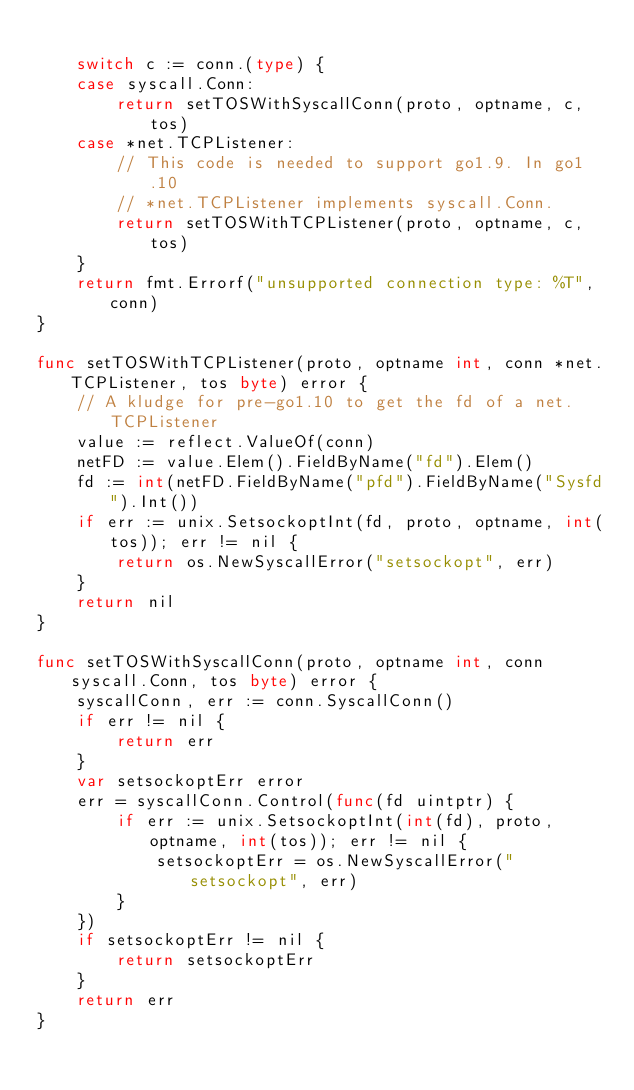<code> <loc_0><loc_0><loc_500><loc_500><_Go_>
	switch c := conn.(type) {
	case syscall.Conn:
		return setTOSWithSyscallConn(proto, optname, c, tos)
	case *net.TCPListener:
		// This code is needed to support go1.9. In go1.10
		// *net.TCPListener implements syscall.Conn.
		return setTOSWithTCPListener(proto, optname, c, tos)
	}
	return fmt.Errorf("unsupported connection type: %T", conn)
}

func setTOSWithTCPListener(proto, optname int, conn *net.TCPListener, tos byte) error {
	// A kludge for pre-go1.10 to get the fd of a net.TCPListener
	value := reflect.ValueOf(conn)
	netFD := value.Elem().FieldByName("fd").Elem()
	fd := int(netFD.FieldByName("pfd").FieldByName("Sysfd").Int())
	if err := unix.SetsockoptInt(fd, proto, optname, int(tos)); err != nil {
		return os.NewSyscallError("setsockopt", err)
	}
	return nil
}

func setTOSWithSyscallConn(proto, optname int, conn syscall.Conn, tos byte) error {
	syscallConn, err := conn.SyscallConn()
	if err != nil {
		return err
	}
	var setsockoptErr error
	err = syscallConn.Control(func(fd uintptr) {
		if err := unix.SetsockoptInt(int(fd), proto, optname, int(tos)); err != nil {
			setsockoptErr = os.NewSyscallError("setsockopt", err)
		}
	})
	if setsockoptErr != nil {
		return setsockoptErr
	}
	return err
}
</code> 